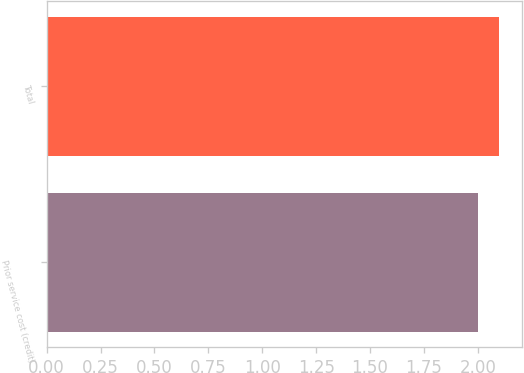Convert chart. <chart><loc_0><loc_0><loc_500><loc_500><bar_chart><fcel>Prior service cost (credit)<fcel>Total<nl><fcel>2<fcel>2.1<nl></chart> 